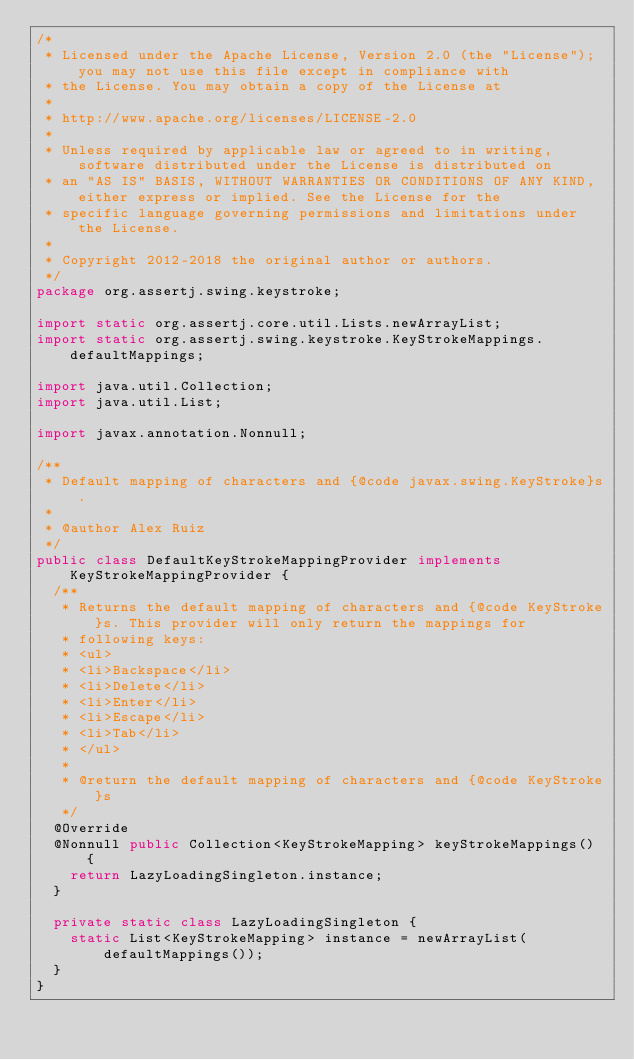<code> <loc_0><loc_0><loc_500><loc_500><_Java_>/*
 * Licensed under the Apache License, Version 2.0 (the "License"); you may not use this file except in compliance with
 * the License. You may obtain a copy of the License at
 *
 * http://www.apache.org/licenses/LICENSE-2.0
 *
 * Unless required by applicable law or agreed to in writing, software distributed under the License is distributed on
 * an "AS IS" BASIS, WITHOUT WARRANTIES OR CONDITIONS OF ANY KIND, either express or implied. See the License for the
 * specific language governing permissions and limitations under the License.
 *
 * Copyright 2012-2018 the original author or authors.
 */
package org.assertj.swing.keystroke;

import static org.assertj.core.util.Lists.newArrayList;
import static org.assertj.swing.keystroke.KeyStrokeMappings.defaultMappings;

import java.util.Collection;
import java.util.List;

import javax.annotation.Nonnull;

/**
 * Default mapping of characters and {@code javax.swing.KeyStroke}s.
 * 
 * @author Alex Ruiz
 */
public class DefaultKeyStrokeMappingProvider implements KeyStrokeMappingProvider {
  /**
   * Returns the default mapping of characters and {@code KeyStroke}s. This provider will only return the mappings for
   * following keys:
   * <ul>
   * <li>Backspace</li>
   * <li>Delete</li>
   * <li>Enter</li>
   * <li>Escape</li>
   * <li>Tab</li>
   * </ul>
   * 
   * @return the default mapping of characters and {@code KeyStroke}s
   */
  @Override
  @Nonnull public Collection<KeyStrokeMapping> keyStrokeMappings() {
    return LazyLoadingSingleton.instance;
  }

  private static class LazyLoadingSingleton {
    static List<KeyStrokeMapping> instance = newArrayList(defaultMappings());
  }
}
</code> 